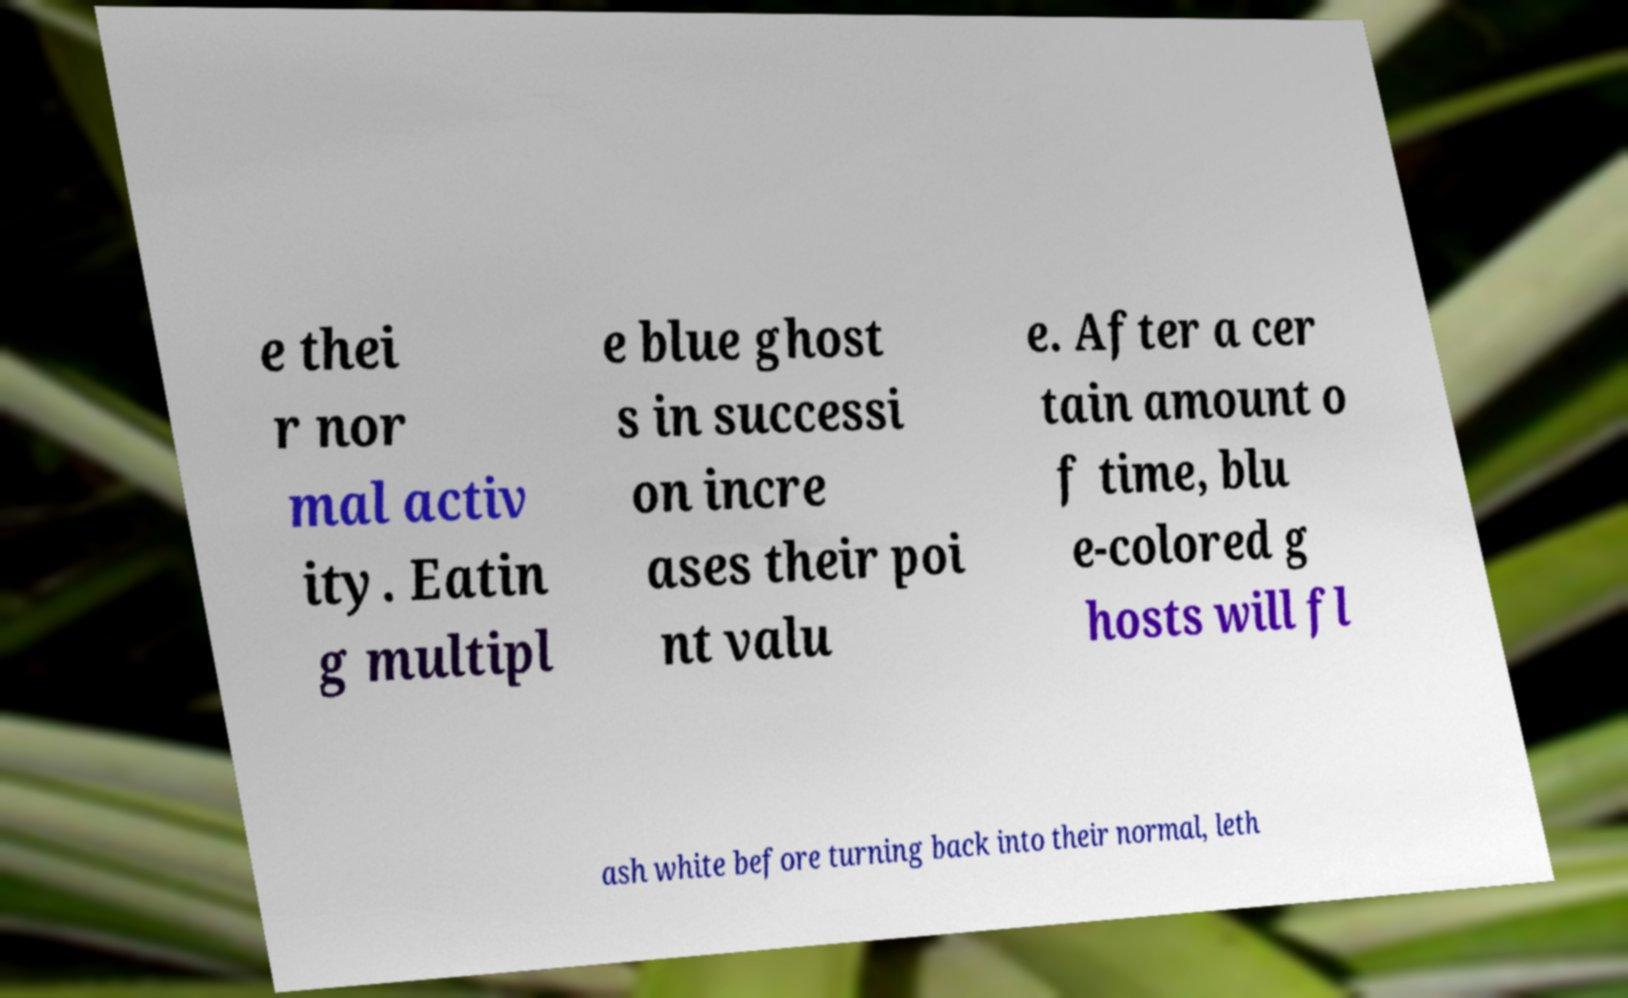Can you accurately transcribe the text from the provided image for me? e thei r nor mal activ ity. Eatin g multipl e blue ghost s in successi on incre ases their poi nt valu e. After a cer tain amount o f time, blu e-colored g hosts will fl ash white before turning back into their normal, leth 